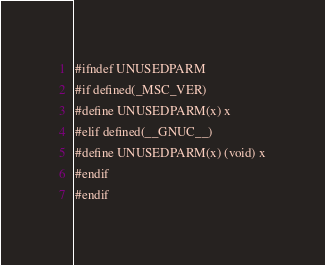Convert code to text. <code><loc_0><loc_0><loc_500><loc_500><_C_>#ifndef UNUSEDPARM
#if defined(_MSC_VER)
#define UNUSEDPARM(x) x
#elif defined(__GNUC__)
#define UNUSEDPARM(x) (void) x
#endif
#endif
</code> 